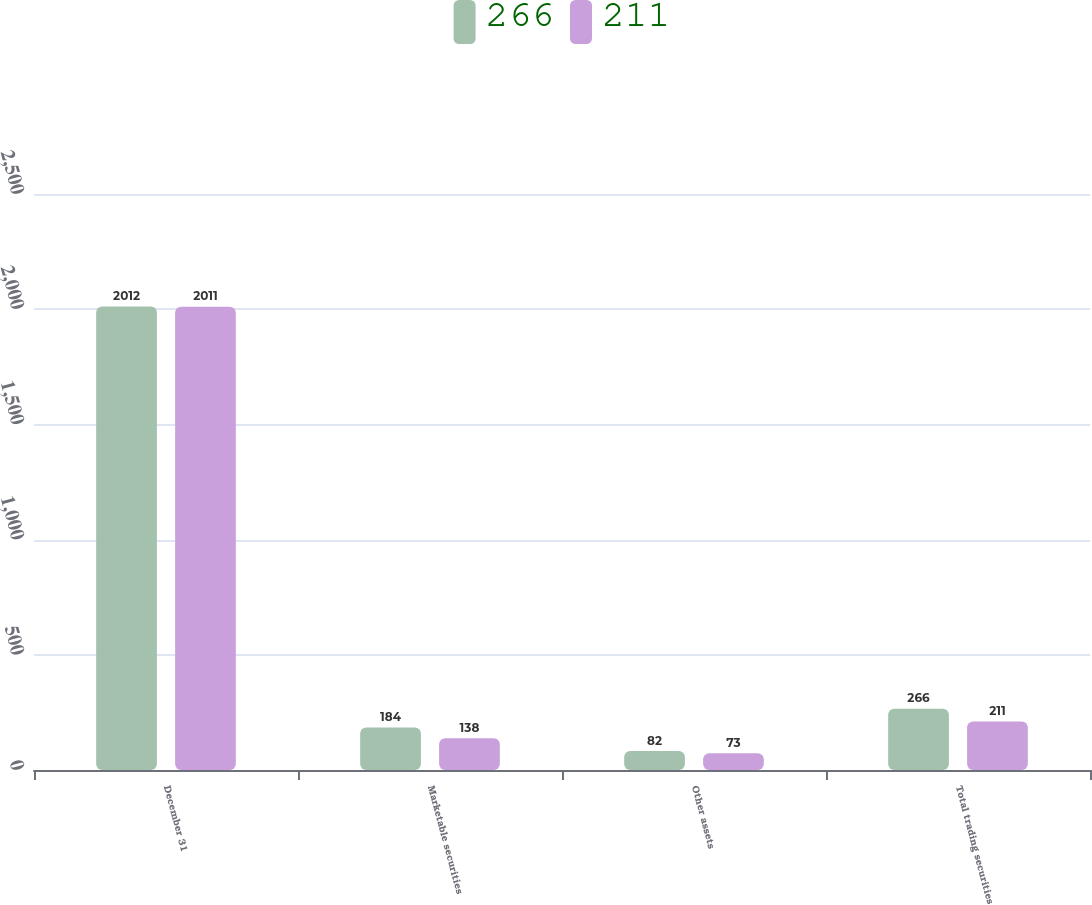<chart> <loc_0><loc_0><loc_500><loc_500><stacked_bar_chart><ecel><fcel>December 31<fcel>Marketable securities<fcel>Other assets<fcel>Total trading securities<nl><fcel>266<fcel>2012<fcel>184<fcel>82<fcel>266<nl><fcel>211<fcel>2011<fcel>138<fcel>73<fcel>211<nl></chart> 